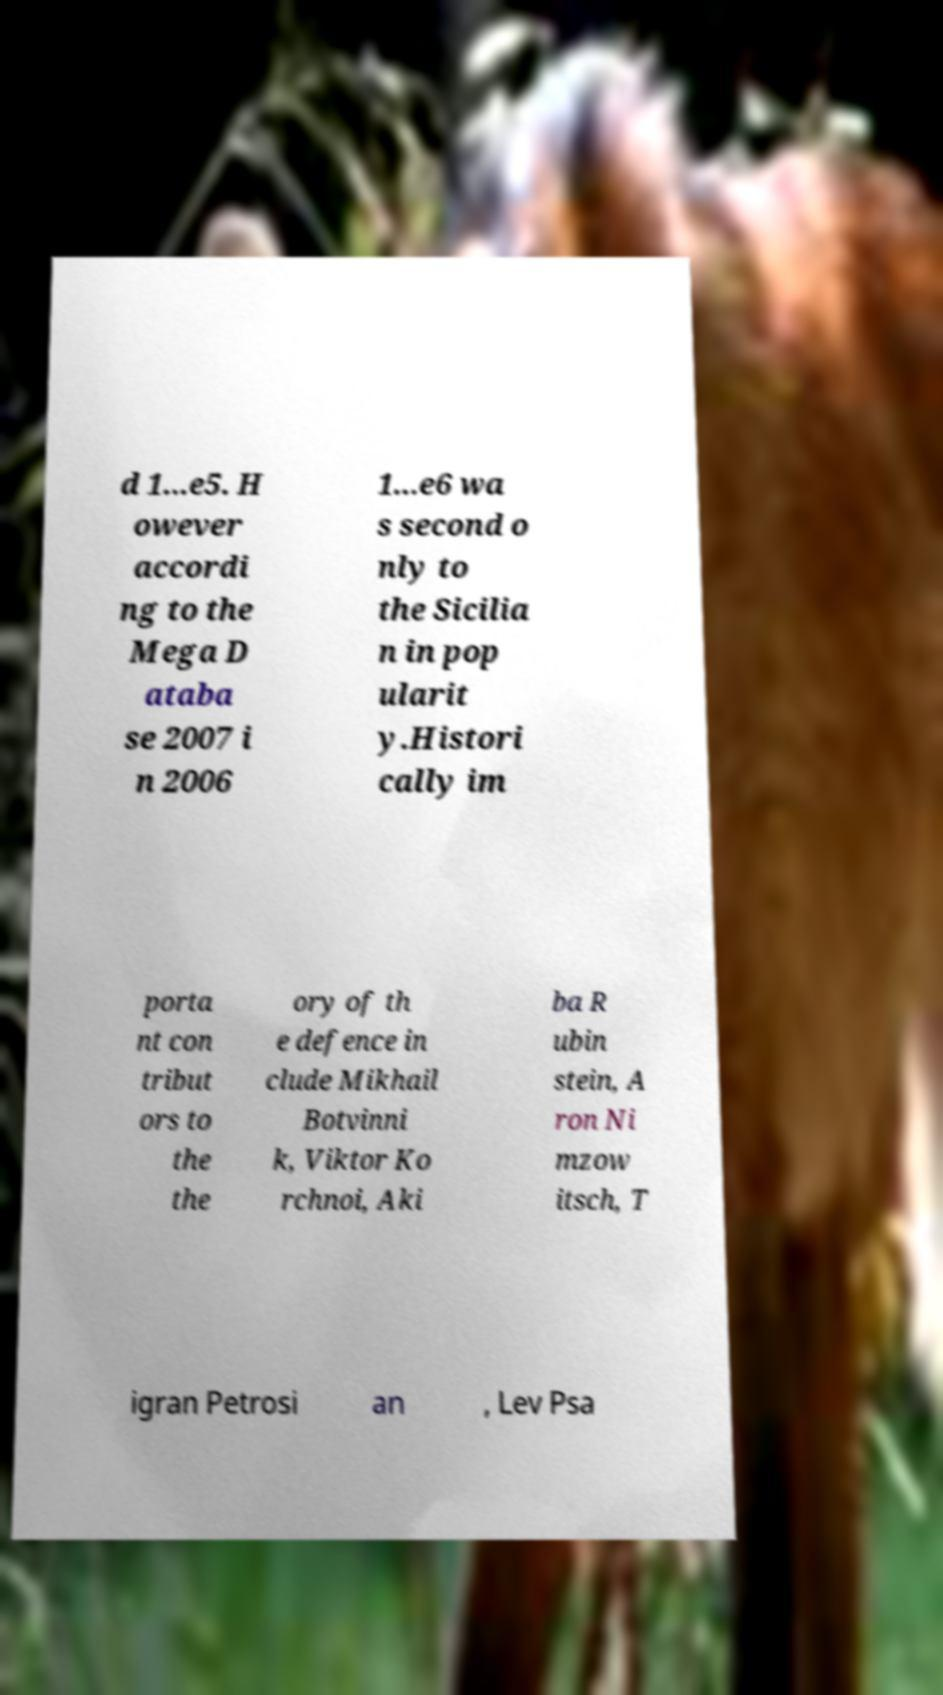Please read and relay the text visible in this image. What does it say? d 1...e5. H owever accordi ng to the Mega D ataba se 2007 i n 2006 1...e6 wa s second o nly to the Sicilia n in pop ularit y.Histori cally im porta nt con tribut ors to the the ory of th e defence in clude Mikhail Botvinni k, Viktor Ko rchnoi, Aki ba R ubin stein, A ron Ni mzow itsch, T igran Petrosi an , Lev Psa 